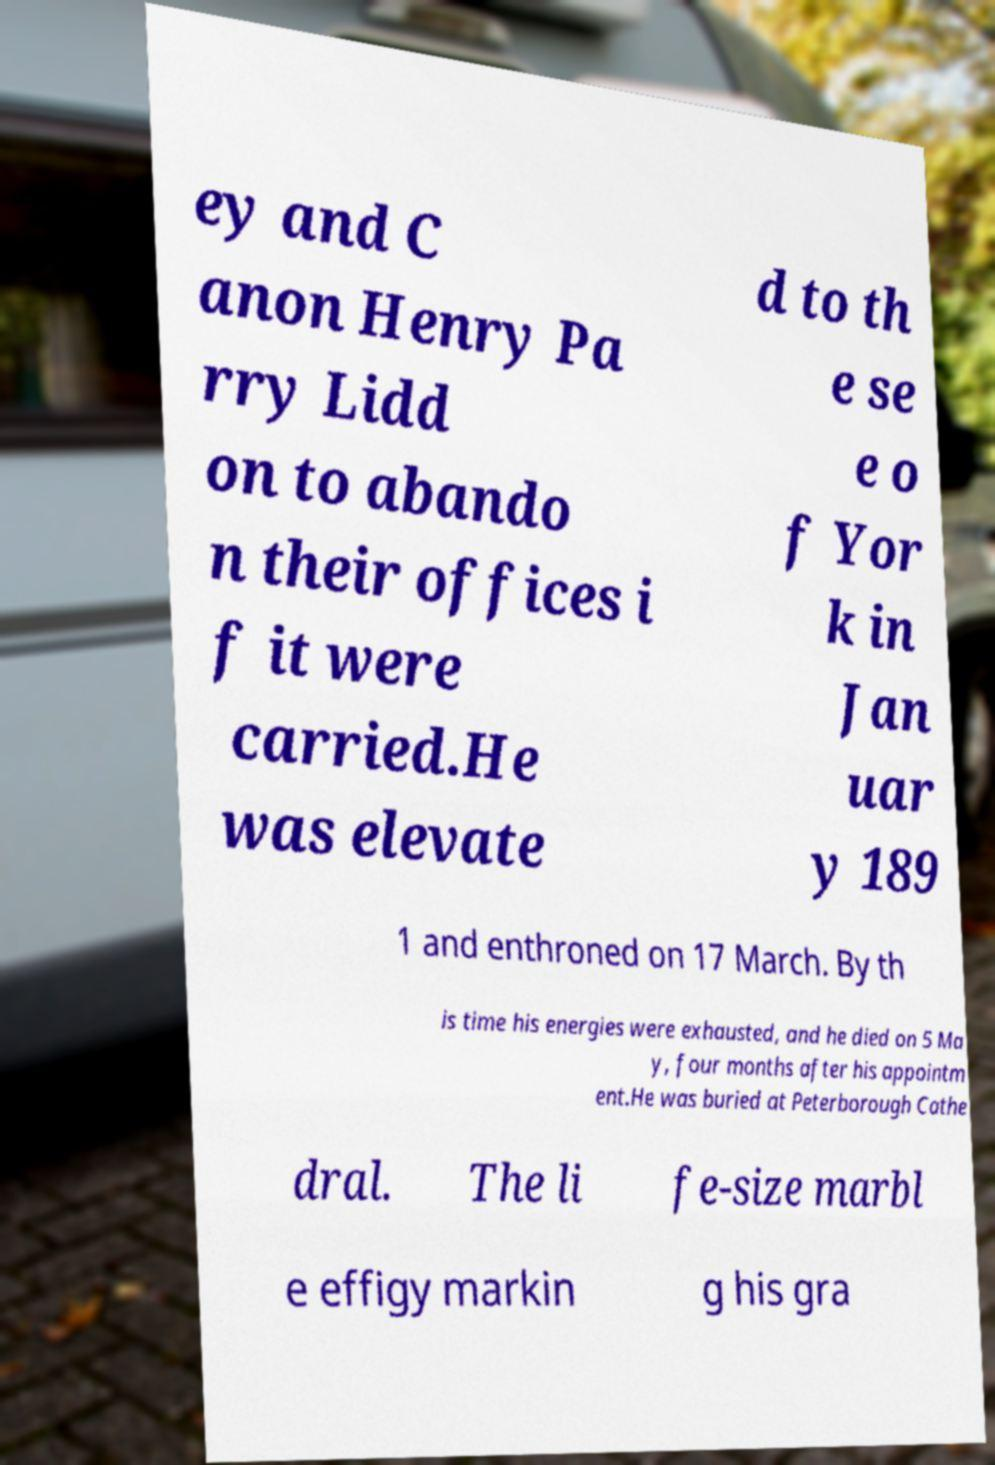Could you assist in decoding the text presented in this image and type it out clearly? ey and C anon Henry Pa rry Lidd on to abando n their offices i f it were carried.He was elevate d to th e se e o f Yor k in Jan uar y 189 1 and enthroned on 17 March. By th is time his energies were exhausted, and he died on 5 Ma y, four months after his appointm ent.He was buried at Peterborough Cathe dral. The li fe-size marbl e effigy markin g his gra 